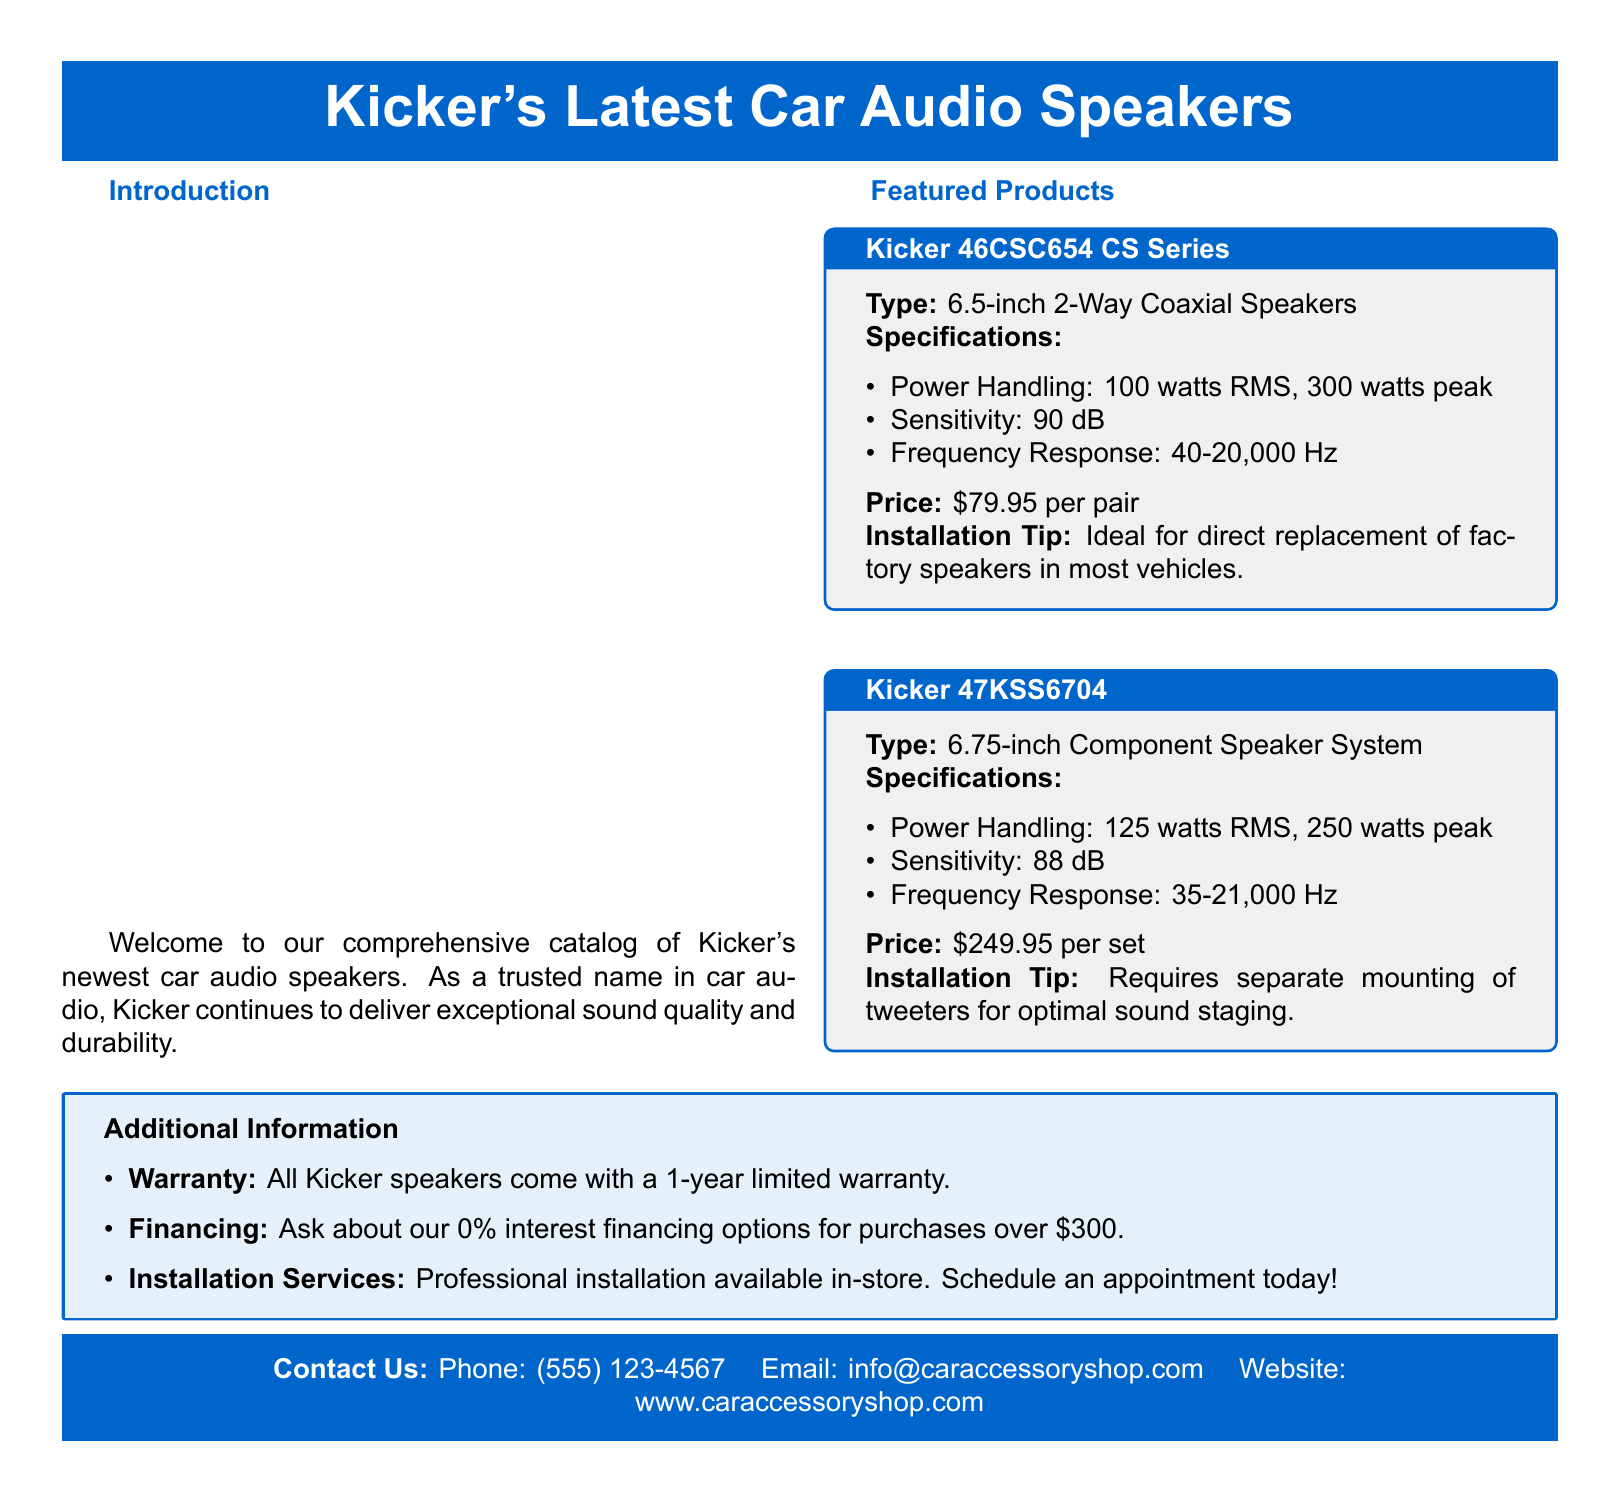What type of speaker is the Kicker 46CSC654? The Kicker 46CSC654 is classified as a 6.5-inch 2-Way Coaxial Speaker.
Answer: 6.5-inch 2-Way Coaxial Speakers What is the power handling of the Kicker 47KSS6704? The Kicker 47KSS6704 has a power handling of 125 watts RMS and 250 watts peak.
Answer: 125 watts RMS, 250 watts peak What is the frequency response range of the Kicker 46CSC654? The frequency response for the Kicker 46CSC654 ranges from 40 to 20,000 Hz.
Answer: 40-20,000 Hz How much do Kicker 47KSS6704 speakers cost? The price for Kicker 47KSS6704 speakers is listed as $249.95 per set.
Answer: $249.95 per set What is the sensitivity rating of the Kicker 47KSS6704? The Kicker 47KSS6704 has a sensitivity rating of 88 dB.
Answer: 88 dB What warranty do Kicker speakers come with? The document states that all Kicker speakers come with a 1-year limited warranty.
Answer: 1-year limited warranty What installation tip is provided for Kicker 46CSC654 speakers? The installation tip for Kicker 46CSC654 speakers is that they are ideal for direct replacement of factory speakers.
Answer: Ideal for direct replacement of factory speakers How can customers contact the store? The document provides a contact method of phone, email, and website for customers to reach the store.
Answer: Phone: (555) 123-4567, Email: info@caraccessoryshop.com, Website: www.caraccessoryshop.com 